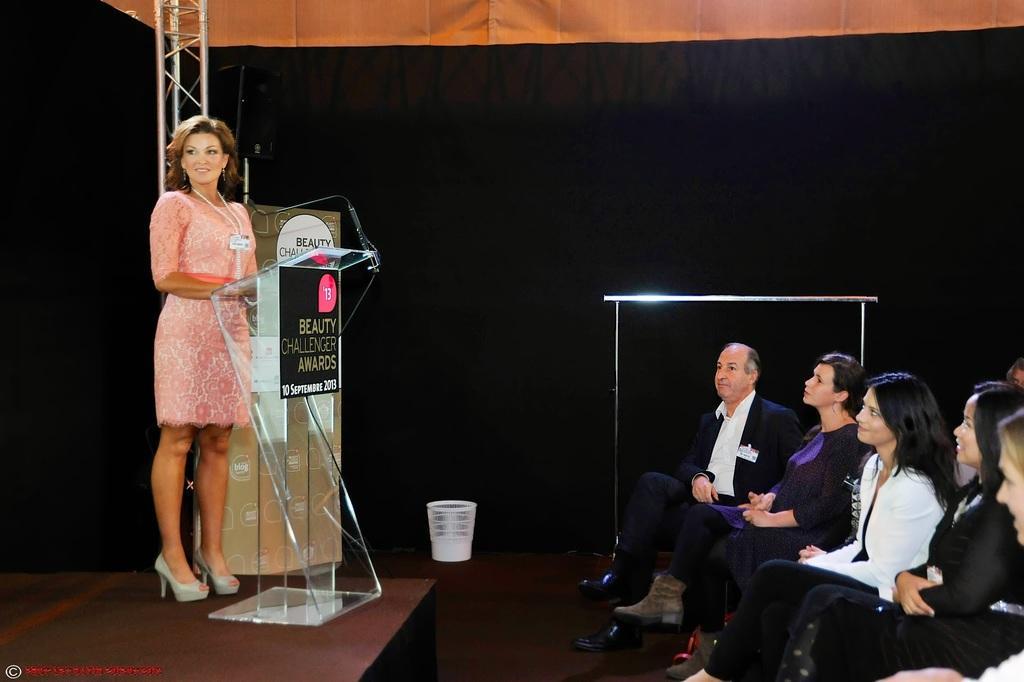Can you describe this image briefly? In this image, we can see a lady standing on the stage on the stage and there is a mic stand. On the right, we can see people sitting on the chairs. In the background, there is curtain. 